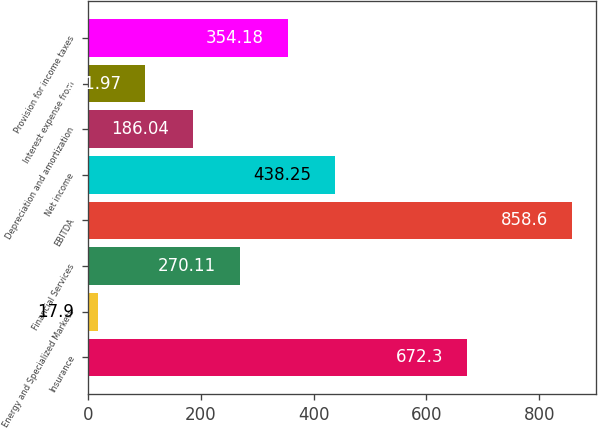<chart> <loc_0><loc_0><loc_500><loc_500><bar_chart><fcel>Insurance<fcel>Energy and Specialized Markets<fcel>Financial Services<fcel>EBITDA<fcel>Net income<fcel>Depreciation and amortization<fcel>Interest expense from<fcel>Provision for income taxes<nl><fcel>672.3<fcel>17.9<fcel>270.11<fcel>858.6<fcel>438.25<fcel>186.04<fcel>101.97<fcel>354.18<nl></chart> 